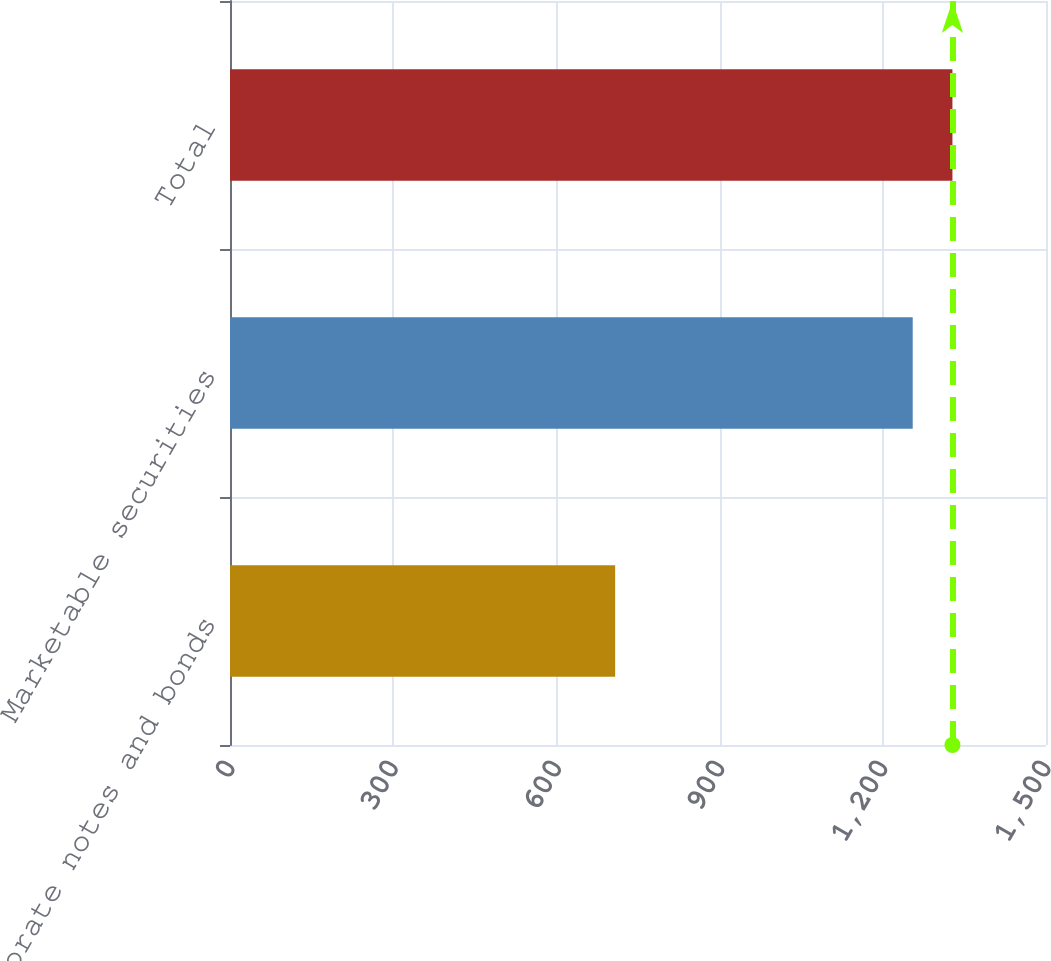Convert chart. <chart><loc_0><loc_0><loc_500><loc_500><bar_chart><fcel>Corporate notes and bonds<fcel>Marketable securities<fcel>Total<nl><fcel>708<fcel>1255<fcel>1328<nl></chart> 